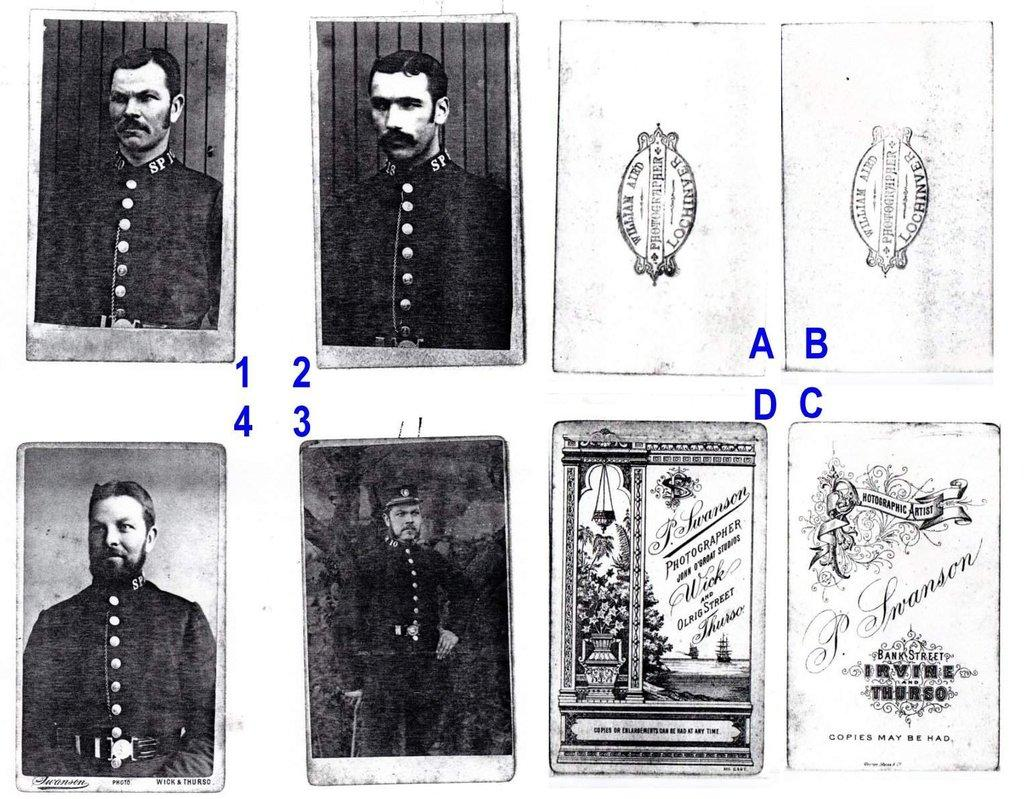How many photo frames are visible in the image? There are eight photo frames in the image. What is the color scheme of the photo frames? The photo frames are in black and white. Where are the photo frames placed in the image? The photo frames are placed on a white wall. What color is used for the writing in the image? The numbers and alphabet are written in blue color in the image. What type of lettuce is growing in the photo frames? There is no lettuce present in the image; the photo frames contain black and white images. 